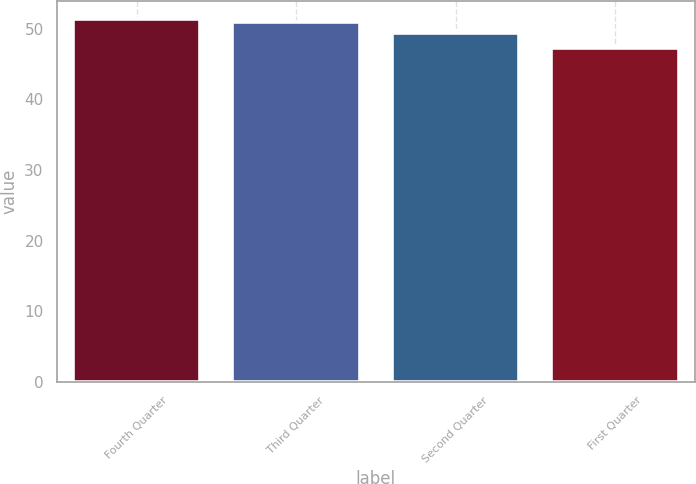Convert chart. <chart><loc_0><loc_0><loc_500><loc_500><bar_chart><fcel>Fourth Quarter<fcel>Third Quarter<fcel>Second Quarter<fcel>First Quarter<nl><fcel>51.35<fcel>50.94<fcel>49.43<fcel>47.33<nl></chart> 